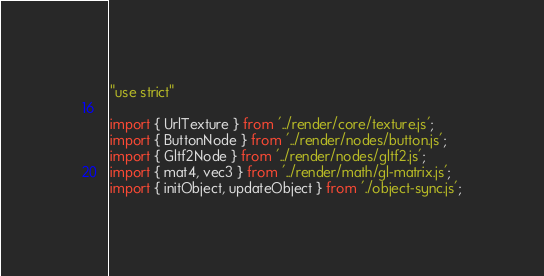Convert code to text. <code><loc_0><loc_0><loc_500><loc_500><_JavaScript_>"use strict"

import { UrlTexture } from '../render/core/texture.js';
import { ButtonNode } from '../render/nodes/button.js';
import { Gltf2Node } from '../render/nodes/gltf2.js';
import { mat4, vec3 } from '../render/math/gl-matrix.js';
import { initObject, updateObject } from './object-sync.js';
</code> 